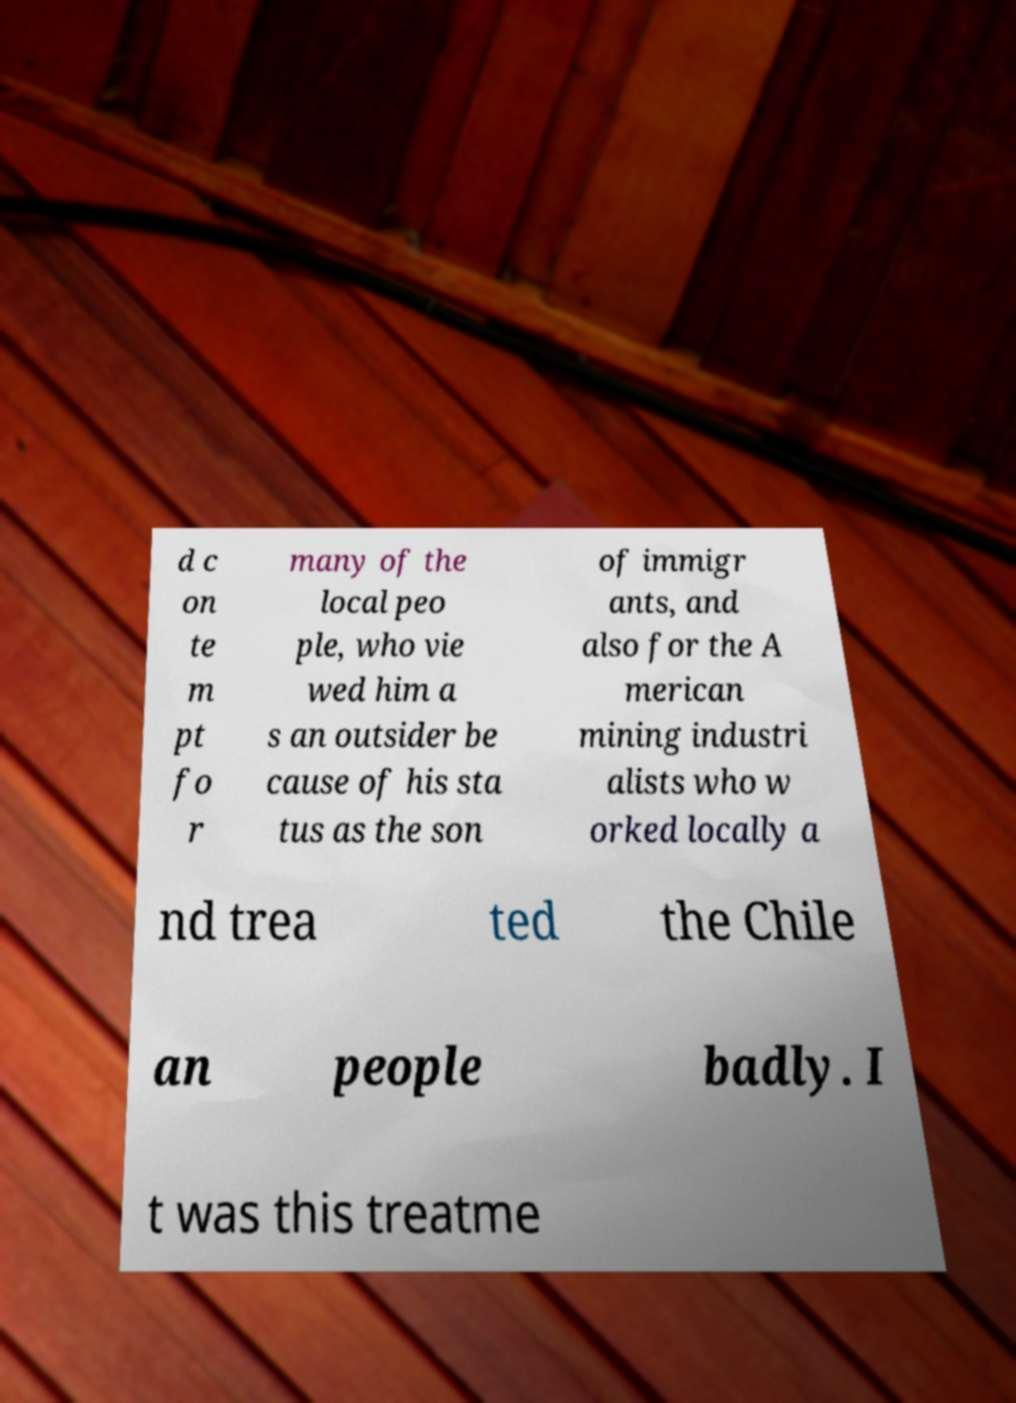Could you assist in decoding the text presented in this image and type it out clearly? d c on te m pt fo r many of the local peo ple, who vie wed him a s an outsider be cause of his sta tus as the son of immigr ants, and also for the A merican mining industri alists who w orked locally a nd trea ted the Chile an people badly. I t was this treatme 